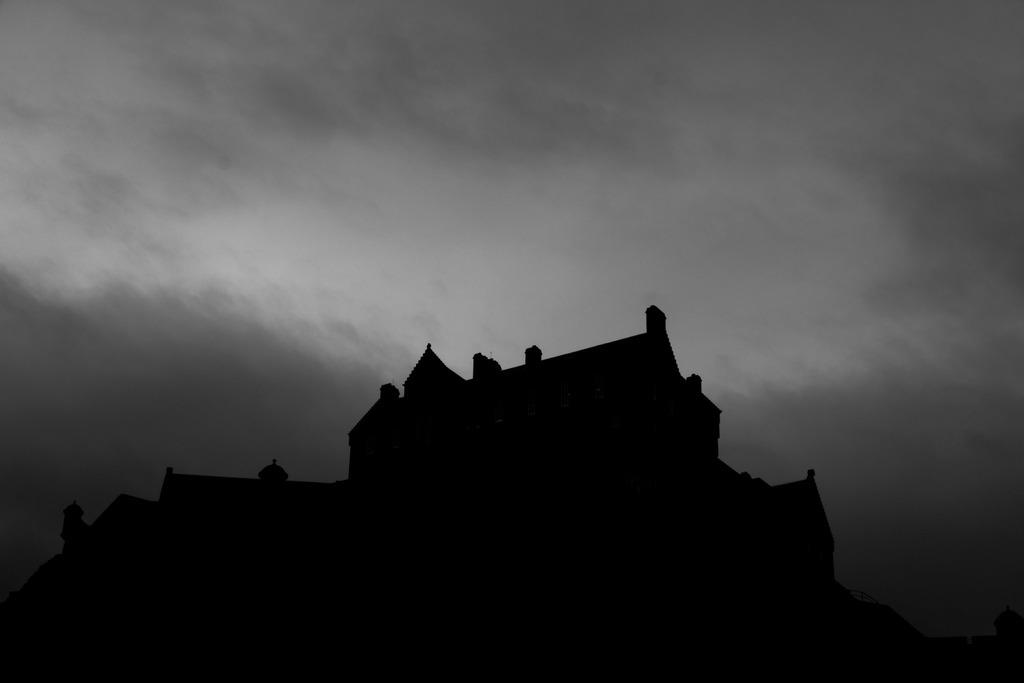What is the color scheme of the image? The image is black and white. What type of structure can be seen at the bottom of the image? There is a building in the dark at the bottom of the image. What part of the natural environment is visible in the image? The sky is visible at the top of the image. How many houses are visible in the sea in the image? There is no sea or houses present in the image; it features a building in the dark and a visible sky. 